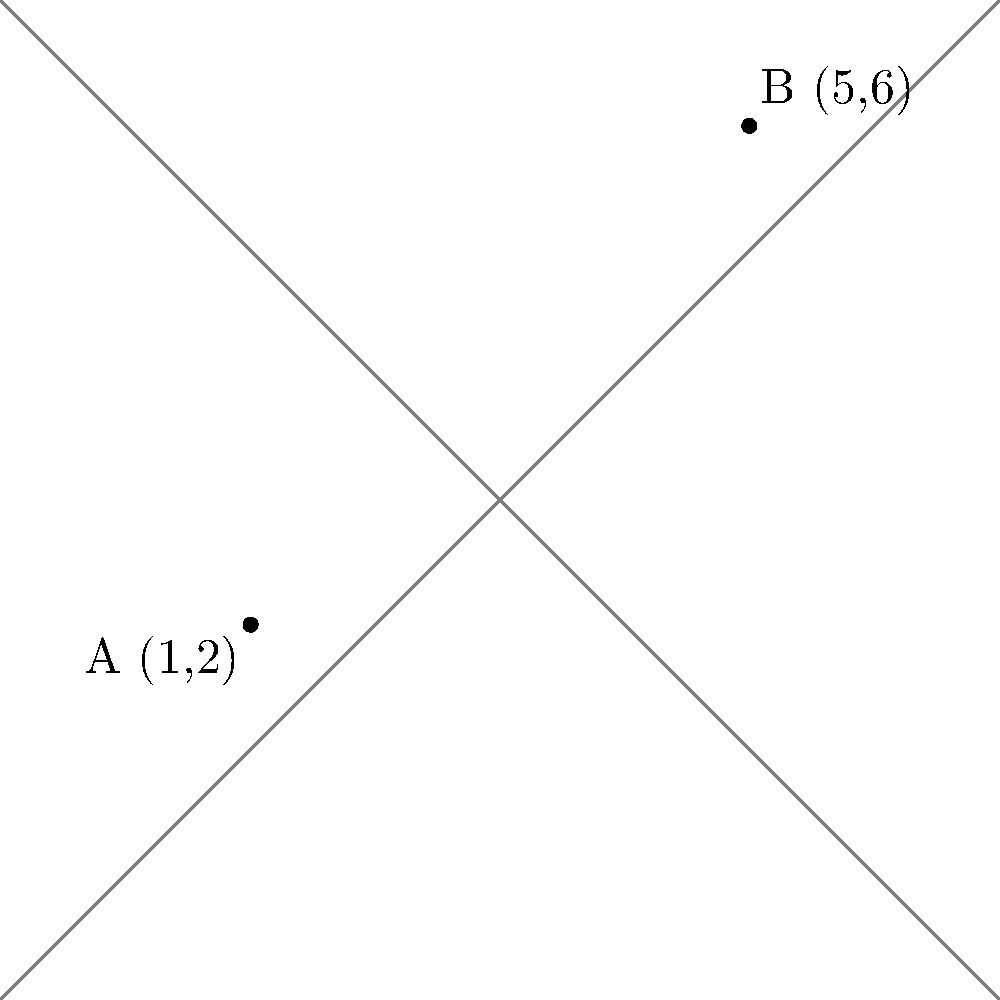In a legal debate, two interpretations of a law are represented by points A (1,2) and B (5,6) on a coordinate plane. Calculate the distance between these two points to quantify the gap between the legal interpretations. Round your answer to two decimal places. To find the distance between two points on a coordinate plane, we can use the distance formula:

$$d = \sqrt{(x_2 - x_1)^2 + (y_2 - y_1)^2}$$

Where $(x_1, y_1)$ represents the coordinates of point A, and $(x_2, y_2)$ represents the coordinates of point B.

Step 1: Identify the coordinates
Point A: $(1, 2)$
Point B: $(5, 6)$

Step 2: Plug the values into the distance formula
$$d = \sqrt{(5 - 1)^2 + (6 - 2)^2}$$

Step 3: Simplify the expressions inside the parentheses
$$d = \sqrt{4^2 + 4^2}$$

Step 4: Calculate the squares
$$d = \sqrt{16 + 16}$$

Step 5: Add the values under the square root
$$d = \sqrt{32}$$

Step 6: Simplify the square root
$$d = 4\sqrt{2}$$

Step 7: Calculate the approximate value and round to two decimal places
$$d \approx 5.66$$

Therefore, the distance between the two points, representing the gap between the legal interpretations, is approximately 5.66 units.
Answer: 5.66 units 